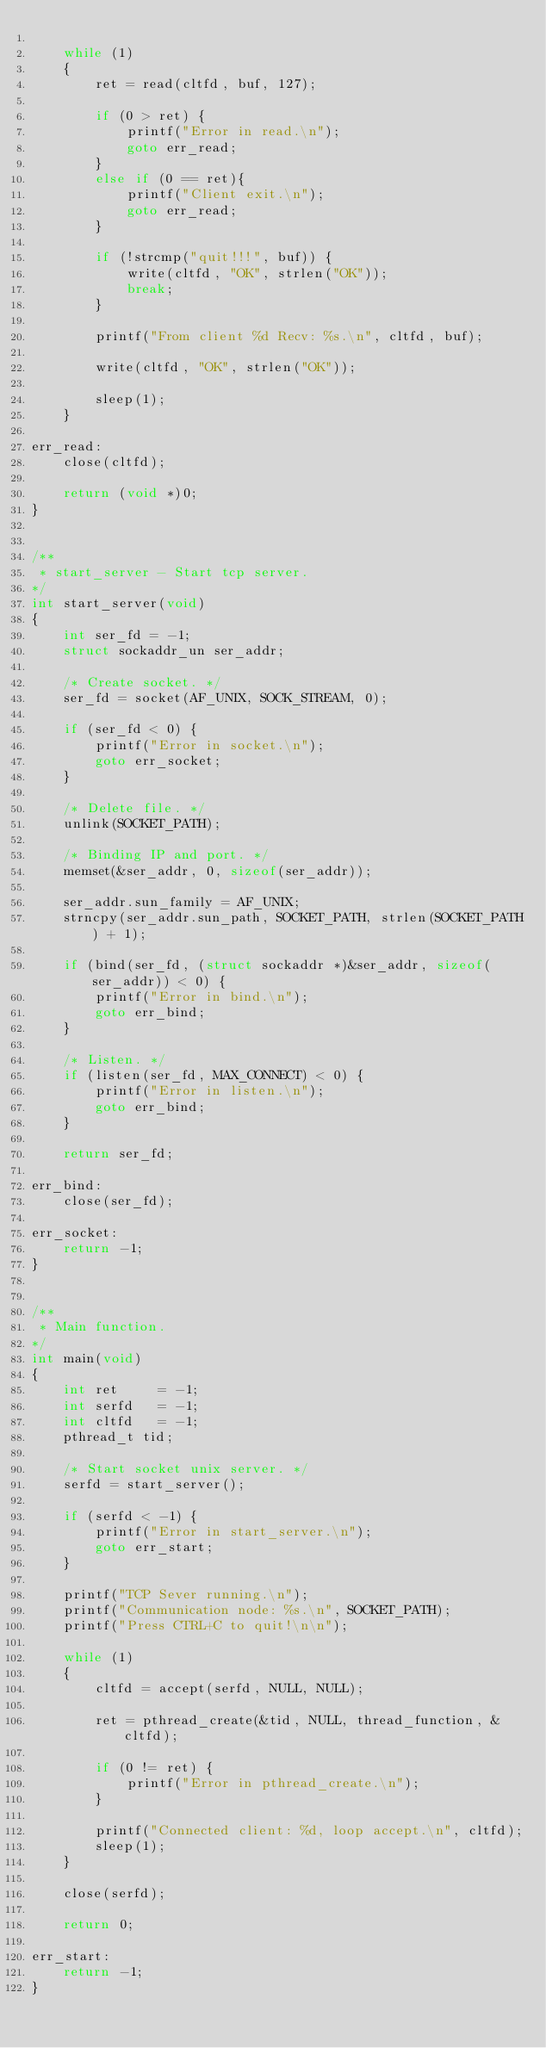Convert code to text. <code><loc_0><loc_0><loc_500><loc_500><_C_>
    while (1)
    {
        ret = read(cltfd, buf, 127);

        if (0 > ret) {
            printf("Error in read.\n");
            goto err_read;
        }
        else if (0 == ret){
            printf("Client exit.\n");
            goto err_read;
        }

        if (!strcmp("quit!!!", buf)) {
            write(cltfd, "OK", strlen("OK"));
            break;
        }

        printf("From client %d Recv: %s.\n", cltfd, buf);

        write(cltfd, "OK", strlen("OK"));

        sleep(1);
    }

err_read:
    close(cltfd);

    return (void *)0;
}


/**
 * start_server - Start tcp server.
*/
int start_server(void)
{
    int ser_fd = -1;
    struct sockaddr_un ser_addr;

    /* Create socket. */
    ser_fd = socket(AF_UNIX, SOCK_STREAM, 0);

    if (ser_fd < 0) {
        printf("Error in socket.\n");
        goto err_socket;
    }

    /* Delete file. */
    unlink(SOCKET_PATH);

    /* Binding IP and port. */
    memset(&ser_addr, 0, sizeof(ser_addr));

    ser_addr.sun_family = AF_UNIX;
    strncpy(ser_addr.sun_path, SOCKET_PATH, strlen(SOCKET_PATH) + 1);

    if (bind(ser_fd, (struct sockaddr *)&ser_addr, sizeof(ser_addr)) < 0) {
        printf("Error in bind.\n");
        goto err_bind;
    }

    /* Listen. */
    if (listen(ser_fd, MAX_CONNECT) < 0) {
        printf("Error in listen.\n");
        goto err_bind;
    }

    return ser_fd;

err_bind:
    close(ser_fd);

err_socket:
    return -1;
}


/**
 * Main function.
*/
int main(void)
{
    int ret     = -1;
    int serfd   = -1;
    int cltfd   = -1;
    pthread_t tid;

    /* Start socket unix server. */
    serfd = start_server();

    if (serfd < -1) {
        printf("Error in start_server.\n");
        goto err_start;
    }

    printf("TCP Sever running.\n");
    printf("Communication node: %s.\n", SOCKET_PATH);
    printf("Press CTRL+C to quit!\n\n");

    while (1)
    {
        cltfd = accept(serfd, NULL, NULL);

        ret = pthread_create(&tid, NULL, thread_function, &cltfd);

        if (0 != ret) {
            printf("Error in pthread_create.\n");
        }

        printf("Connected client: %d, loop accept.\n", cltfd);
        sleep(1);
    }
    
    close(serfd);

    return 0;

err_start:
    return -1;
}
</code> 